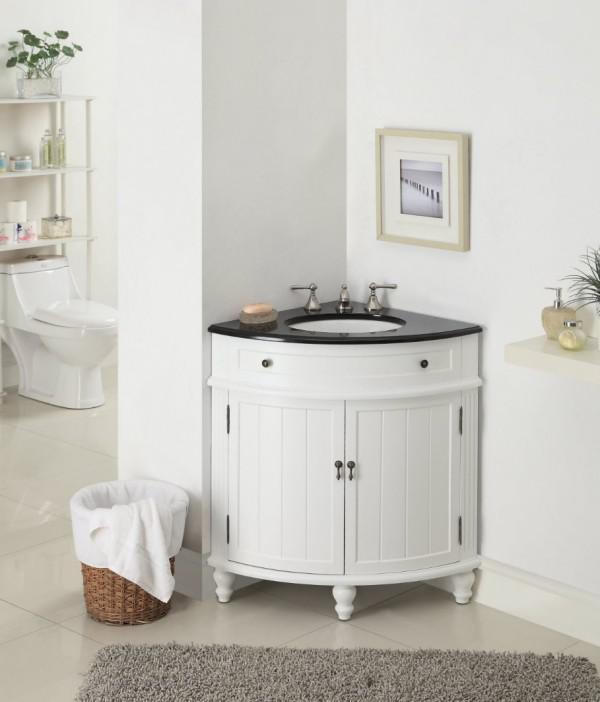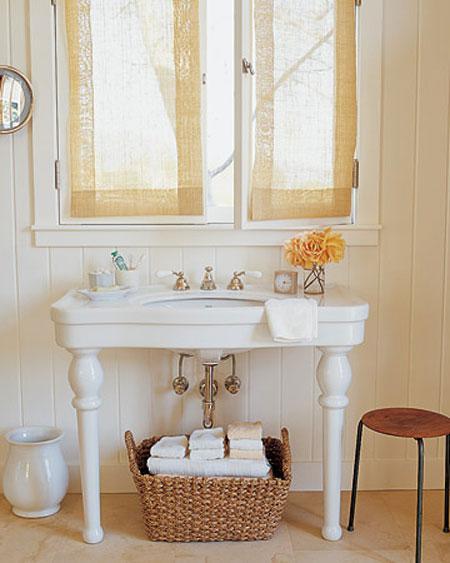The first image is the image on the left, the second image is the image on the right. Given the left and right images, does the statement "There is a sink in one of the images." hold true? Answer yes or no. Yes. 